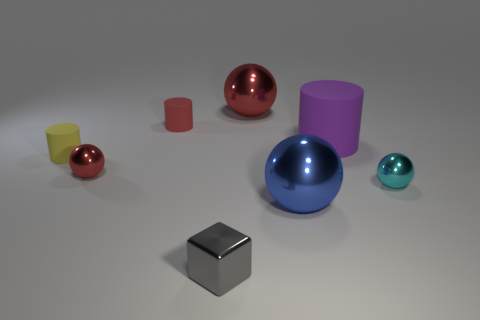What can you infer about the lighting and surface in the scene? The scene appears to be softly lit, giving off a sense of diffuse, ambient light, which casts soft shadows beneath the objects. The surface on which the objects rest seems slightly reflective with a matte finish, allowing for subtle reflections of the objects, especially noticeable beneath the shiny spheres. 